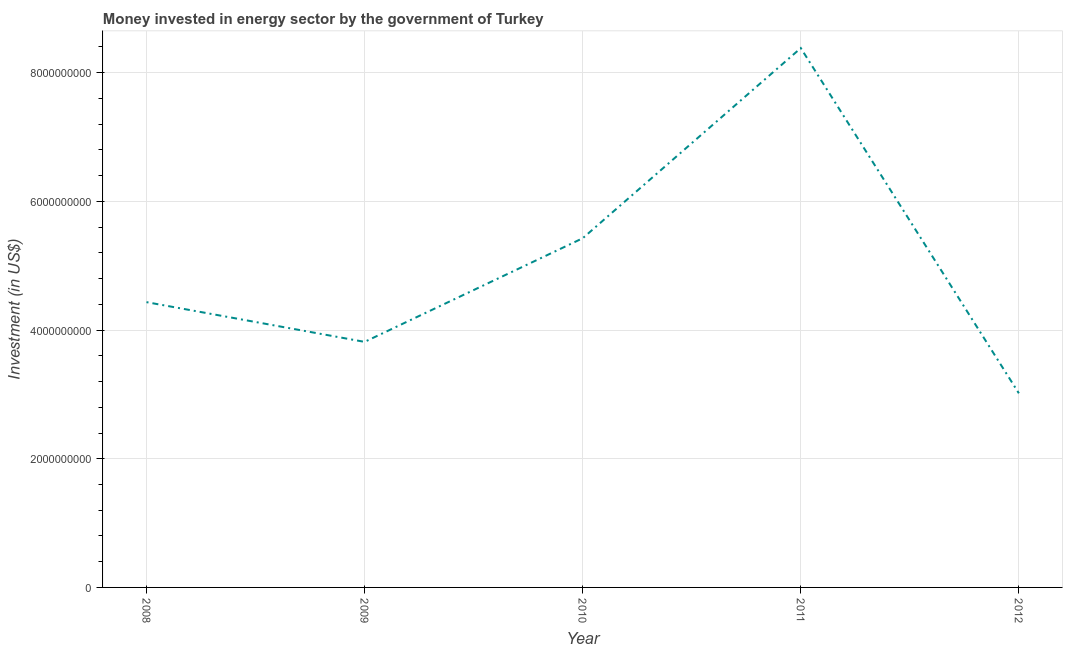What is the investment in energy in 2011?
Your answer should be very brief. 8.38e+09. Across all years, what is the maximum investment in energy?
Your response must be concise. 8.38e+09. Across all years, what is the minimum investment in energy?
Your answer should be compact. 3.02e+09. In which year was the investment in energy minimum?
Make the answer very short. 2012. What is the sum of the investment in energy?
Offer a very short reply. 2.51e+1. What is the difference between the investment in energy in 2010 and 2011?
Make the answer very short. -2.96e+09. What is the average investment in energy per year?
Provide a short and direct response. 5.02e+09. What is the median investment in energy?
Your response must be concise. 4.43e+09. In how many years, is the investment in energy greater than 400000000 US$?
Offer a terse response. 5. What is the ratio of the investment in energy in 2008 to that in 2012?
Offer a very short reply. 1.47. Is the difference between the investment in energy in 2009 and 2012 greater than the difference between any two years?
Provide a short and direct response. No. What is the difference between the highest and the second highest investment in energy?
Your answer should be very brief. 2.96e+09. Is the sum of the investment in energy in 2008 and 2011 greater than the maximum investment in energy across all years?
Your answer should be compact. Yes. What is the difference between the highest and the lowest investment in energy?
Your answer should be compact. 5.37e+09. Does the investment in energy monotonically increase over the years?
Make the answer very short. No. How many lines are there?
Your answer should be very brief. 1. How many years are there in the graph?
Provide a short and direct response. 5. What is the difference between two consecutive major ticks on the Y-axis?
Make the answer very short. 2.00e+09. Are the values on the major ticks of Y-axis written in scientific E-notation?
Make the answer very short. No. Does the graph contain any zero values?
Your answer should be very brief. No. Does the graph contain grids?
Ensure brevity in your answer.  Yes. What is the title of the graph?
Ensure brevity in your answer.  Money invested in energy sector by the government of Turkey. What is the label or title of the X-axis?
Your response must be concise. Year. What is the label or title of the Y-axis?
Keep it short and to the point. Investment (in US$). What is the Investment (in US$) in 2008?
Your answer should be compact. 4.43e+09. What is the Investment (in US$) of 2009?
Your response must be concise. 3.82e+09. What is the Investment (in US$) of 2010?
Your answer should be very brief. 5.43e+09. What is the Investment (in US$) in 2011?
Your answer should be very brief. 8.38e+09. What is the Investment (in US$) of 2012?
Make the answer very short. 3.02e+09. What is the difference between the Investment (in US$) in 2008 and 2009?
Offer a very short reply. 6.18e+08. What is the difference between the Investment (in US$) in 2008 and 2010?
Give a very brief answer. -9.93e+08. What is the difference between the Investment (in US$) in 2008 and 2011?
Make the answer very short. -3.95e+09. What is the difference between the Investment (in US$) in 2008 and 2012?
Offer a very short reply. 1.42e+09. What is the difference between the Investment (in US$) in 2009 and 2010?
Offer a terse response. -1.61e+09. What is the difference between the Investment (in US$) in 2009 and 2011?
Keep it short and to the point. -4.57e+09. What is the difference between the Investment (in US$) in 2009 and 2012?
Provide a succinct answer. 8.00e+08. What is the difference between the Investment (in US$) in 2010 and 2011?
Provide a succinct answer. -2.96e+09. What is the difference between the Investment (in US$) in 2010 and 2012?
Make the answer very short. 2.41e+09. What is the difference between the Investment (in US$) in 2011 and 2012?
Offer a very short reply. 5.37e+09. What is the ratio of the Investment (in US$) in 2008 to that in 2009?
Give a very brief answer. 1.16. What is the ratio of the Investment (in US$) in 2008 to that in 2010?
Your response must be concise. 0.82. What is the ratio of the Investment (in US$) in 2008 to that in 2011?
Offer a terse response. 0.53. What is the ratio of the Investment (in US$) in 2008 to that in 2012?
Offer a very short reply. 1.47. What is the ratio of the Investment (in US$) in 2009 to that in 2010?
Give a very brief answer. 0.7. What is the ratio of the Investment (in US$) in 2009 to that in 2011?
Offer a very short reply. 0.46. What is the ratio of the Investment (in US$) in 2009 to that in 2012?
Provide a short and direct response. 1.26. What is the ratio of the Investment (in US$) in 2010 to that in 2011?
Provide a succinct answer. 0.65. What is the ratio of the Investment (in US$) in 2010 to that in 2012?
Make the answer very short. 1.8. What is the ratio of the Investment (in US$) in 2011 to that in 2012?
Offer a very short reply. 2.78. 